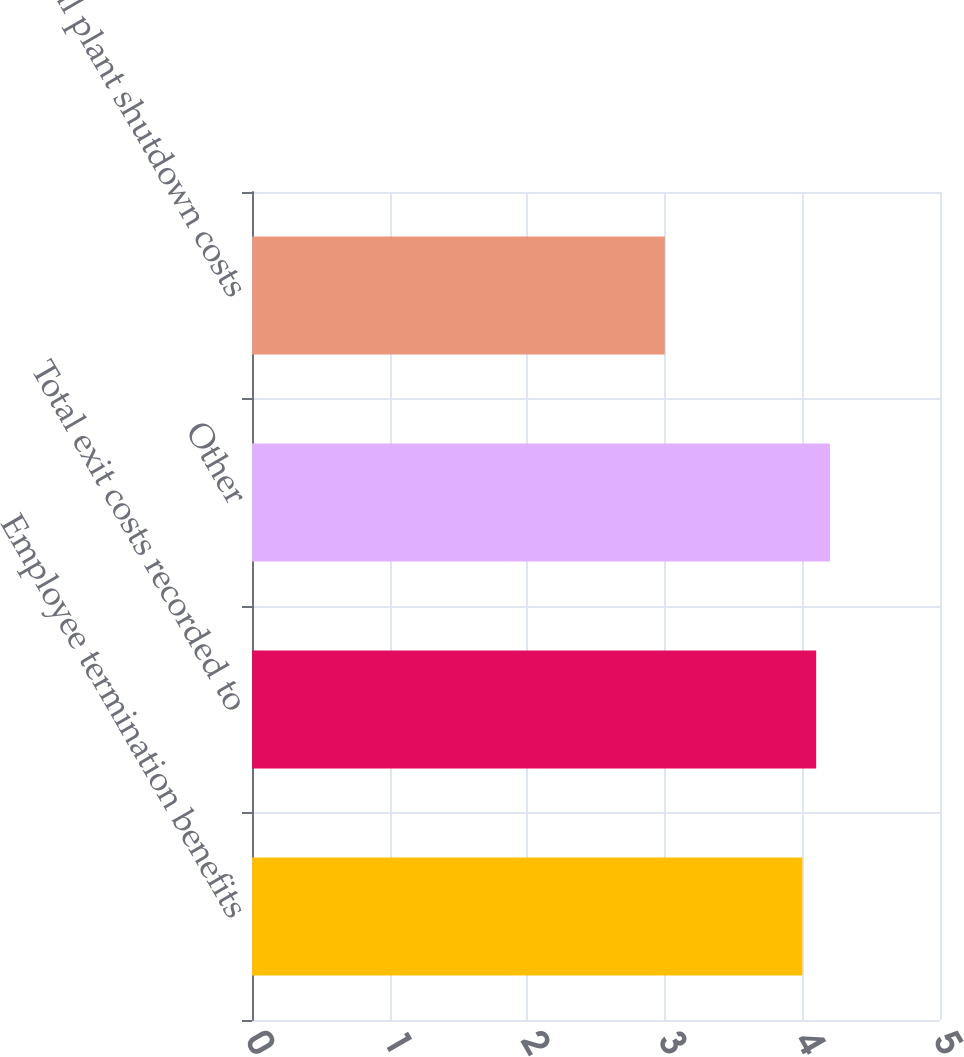Convert chart. <chart><loc_0><loc_0><loc_500><loc_500><bar_chart><fcel>Employee termination benefits<fcel>Total exit costs recorded to<fcel>Other<fcel>Total plant shutdown costs<nl><fcel>4<fcel>4.1<fcel>4.2<fcel>3<nl></chart> 